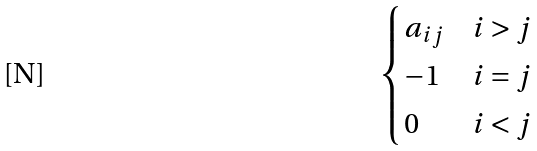Convert formula to latex. <formula><loc_0><loc_0><loc_500><loc_500>\begin{cases} a _ { i j } & i > j \\ - 1 & i = j \\ 0 & i < j \end{cases}</formula> 